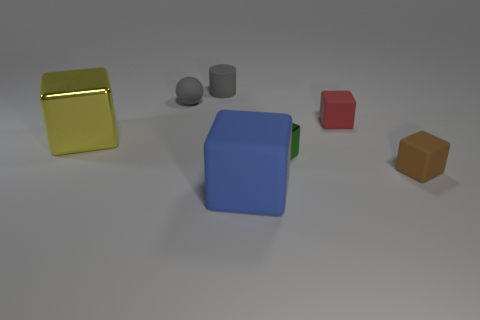Add 1 big metallic cylinders. How many objects exist? 8 Subtract all big blue rubber cubes. How many cubes are left? 4 Subtract all cylinders. How many objects are left? 6 Subtract all blue cubes. How many cubes are left? 4 Subtract 0 cyan cylinders. How many objects are left? 7 Subtract all cyan cubes. Subtract all purple balls. How many cubes are left? 5 Subtract all small blocks. Subtract all big matte things. How many objects are left? 3 Add 7 green metallic blocks. How many green metallic blocks are left? 8 Add 1 green blocks. How many green blocks exist? 2 